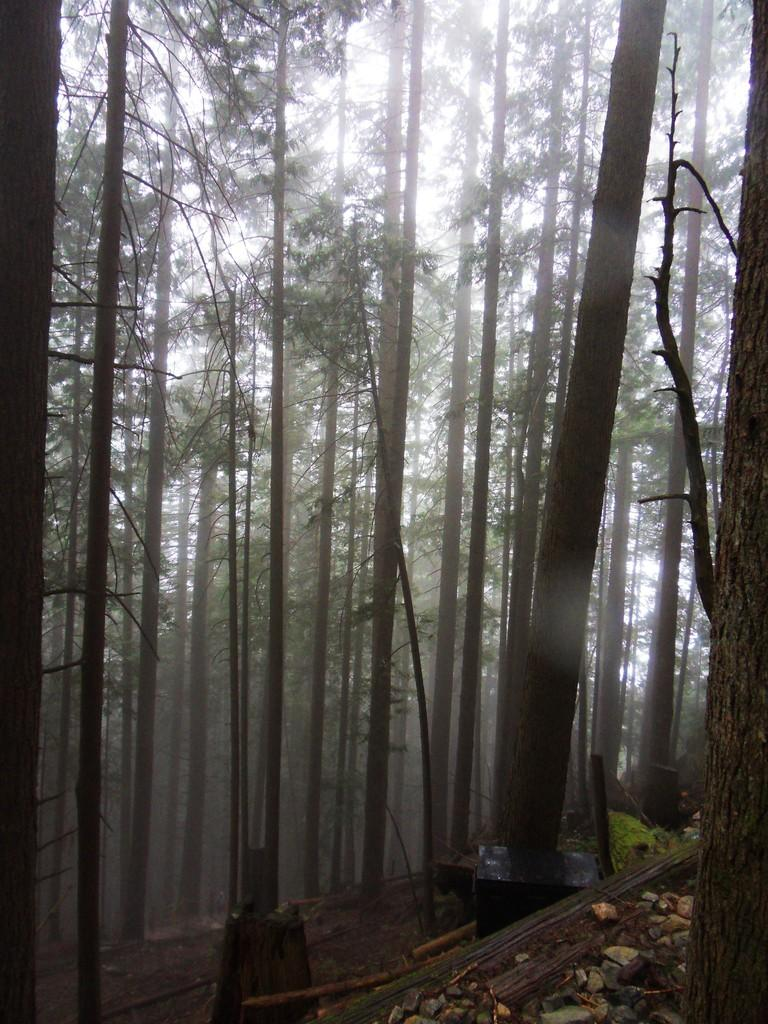What is located at the bottom of the image? There are rocks at the bottom of the image. What type of natural elements can be seen in the background of the image? There are trees in the background of the image. What type of twig is causing the rocks to move in the image? There is no twig present in the image, and the rocks are not moving. How does the nail contribute to the growth of the trees in the image? There is no nail present in the image, and it does not contribute to the growth of the trees. 